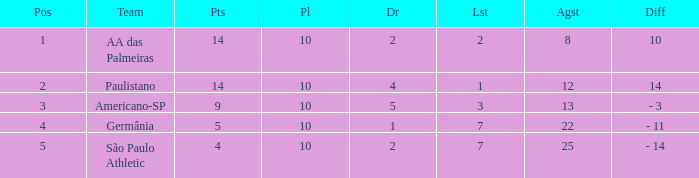What team has an against more than 8, lost of 7, and the position is 5? São Paulo Athletic. Can you parse all the data within this table? {'header': ['Pos', 'Team', 'Pts', 'Pl', 'Dr', 'Lst', 'Agst', 'Diff'], 'rows': [['1', 'AA das Palmeiras', '14', '10', '2', '2', '8', '10'], ['2', 'Paulistano', '14', '10', '4', '1', '12', '14'], ['3', 'Americano-SP', '9', '10', '5', '3', '13', '- 3'], ['4', 'Germânia', '5', '10', '1', '7', '22', '- 11'], ['5', 'São Paulo Athletic', '4', '10', '2', '7', '25', '- 14']]} 